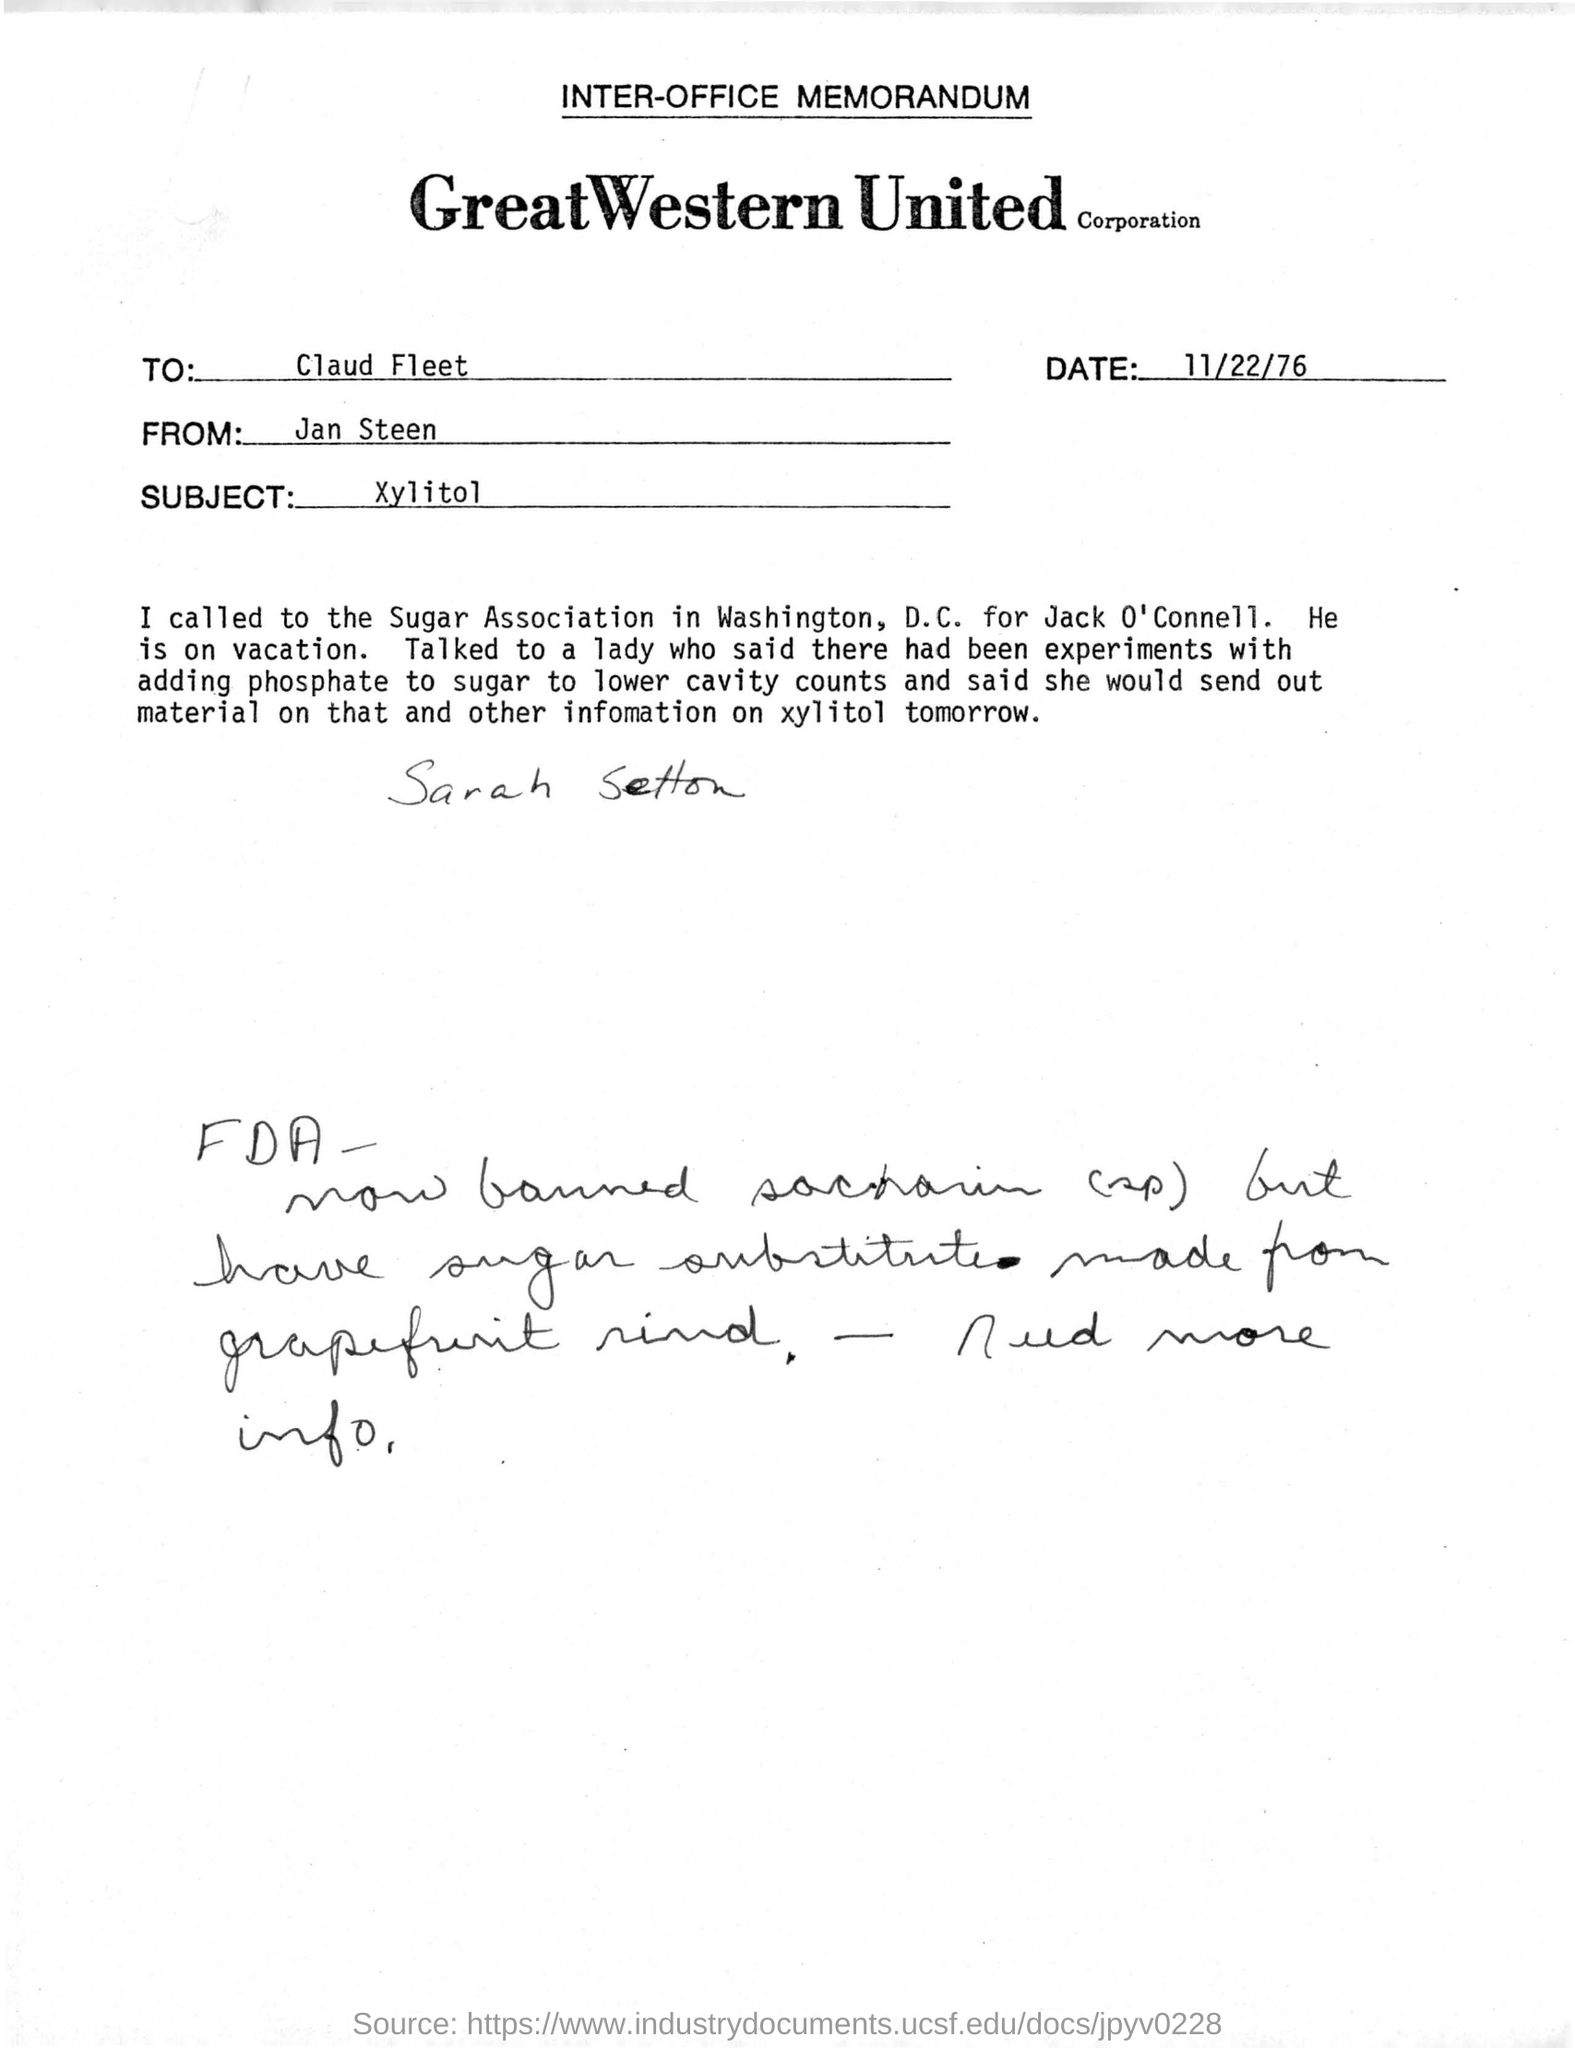Mention a couple of crucial points in this snapshot. The memorandum is dated November 22, 1976. Who is the receiver of the email, Claud Fleet? The sender of this memorandum is Jan Steen. The name written by hand below the content of the memo is Sarah Setton. The memorandum belongs to Great Western United Corporation. 